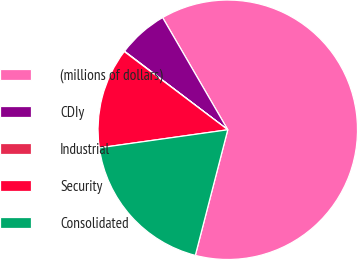Convert chart to OTSL. <chart><loc_0><loc_0><loc_500><loc_500><pie_chart><fcel>(millions of dollars)<fcel>CDIy<fcel>Industrial<fcel>Security<fcel>Consolidated<nl><fcel>62.39%<fcel>6.28%<fcel>0.05%<fcel>12.52%<fcel>18.75%<nl></chart> 